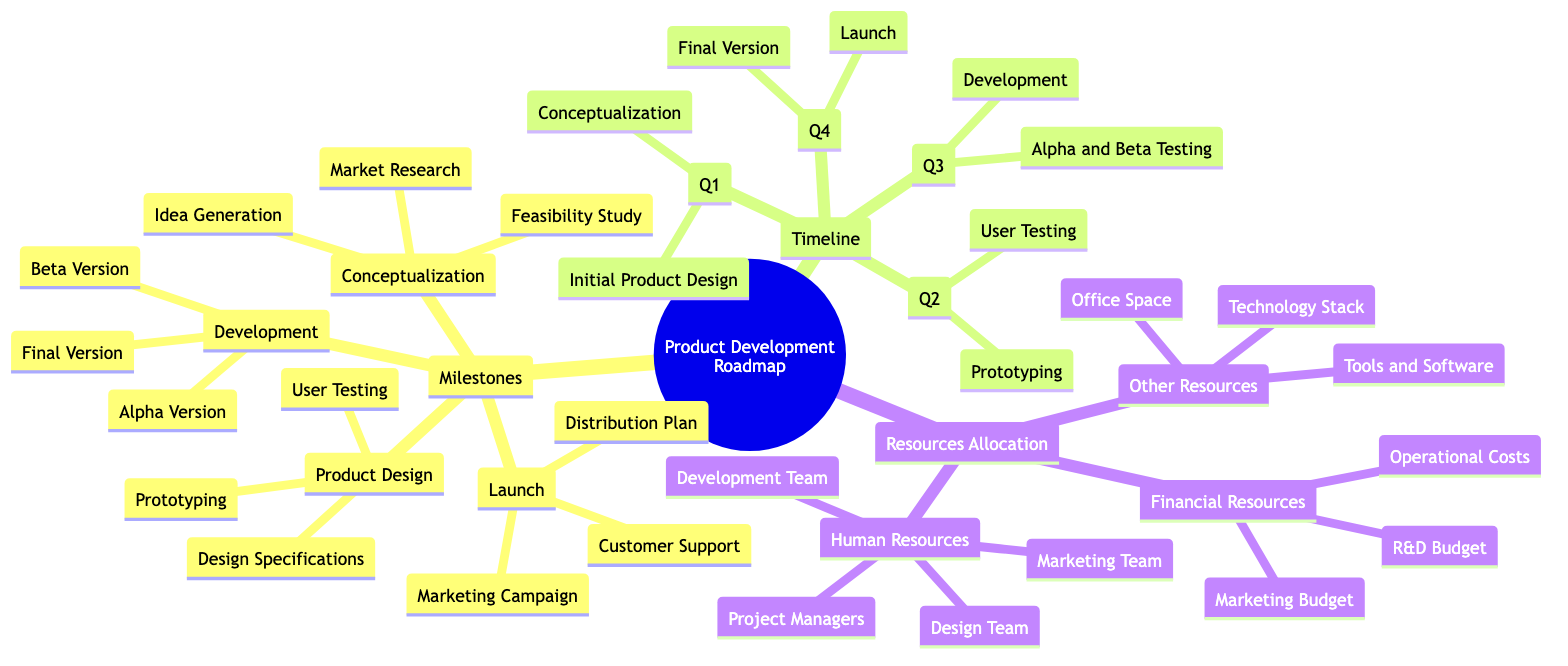What are the first two milestones in the Product Development Roadmap? The first two milestones listed under "Milestones" are "Conceptualization" and "Product Design." This is derived directly from the hierarchical structure of the diagram.
Answer: Conceptualization, Product Design How many phases are in the "Development" milestone? The "Development" milestone includes three phases: "Alpha Version," "Beta Version," and "Final Version." These phases can be counted directly under the "Development" node in the diagram.
Answer: 3 In which quarter do we conduct user testing? User Testing occurs in Q2, as indicated in the "Timeline" section where it lists "User Testing" under Q2.
Answer: Q2 What percentage of the annual budget is allocated for the R&D budget? The diagram states that "20% of annual budget" is set aside for the R&D budget under the "Financial Resources" section.
Answer: 20% Which resource team consists of 5-10 members? The "Development Team" is mentioned to consist of "5-10 software developers," identifying it as the resource team with that specific member count.
Answer: Development Team What comes after the "Alpha Version" in the Development stage? The next phase after "Alpha Version" is the "Beta Version," which is listed in a sequence under the "Development" milestone.
Answer: Beta Version How many main categories are under "Resources Allocation"? There are three main categories listed under "Resources Allocation": "Human Resources," "Financial Resources," and "Other Resources." The number can be counted from the diagram structure.
Answer: 3 Which quarter is dedicated to the final version and product launch? "Final Version" and "Launch" are both scheduled for Q4, as indicated in the "Timeline" section of the diagram.
Answer: Q4 What is the main purpose of the "Marketing Campaign"? The "Marketing Campaign" is aimed at planning and executing the marketing strategy, as stated in the "Launch" milestone of the diagram.
Answer: Plan and execute marketing strategy 